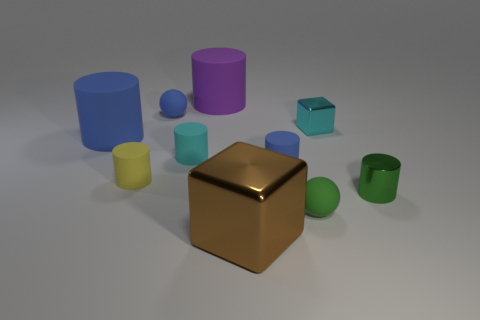How many things are small blue rubber cylinders or tiny yellow rubber cylinders?
Provide a short and direct response. 2. There is a small blue thing that is to the left of the shiny thing in front of the green matte sphere; what is its shape?
Provide a short and direct response. Sphere. There is a small rubber object in front of the yellow cylinder; does it have the same shape as the small yellow object?
Provide a short and direct response. No. There is another brown cube that is made of the same material as the tiny cube; what is its size?
Offer a terse response. Large. How many things are either tiny cylinders that are left of the tiny cube or large things in front of the metal cylinder?
Ensure brevity in your answer.  4. Are there an equal number of small yellow cylinders behind the green metallic object and big blue things that are to the right of the tiny yellow thing?
Provide a succinct answer. No. The matte object in front of the shiny cylinder is what color?
Provide a succinct answer. Green. There is a small metallic cylinder; is its color the same as the small sphere to the left of the brown metallic thing?
Keep it short and to the point. No. Are there fewer big brown metallic things than matte cylinders?
Provide a short and direct response. Yes. There is a metallic object that is behind the big blue rubber thing; is it the same color as the large cube?
Ensure brevity in your answer.  No. 